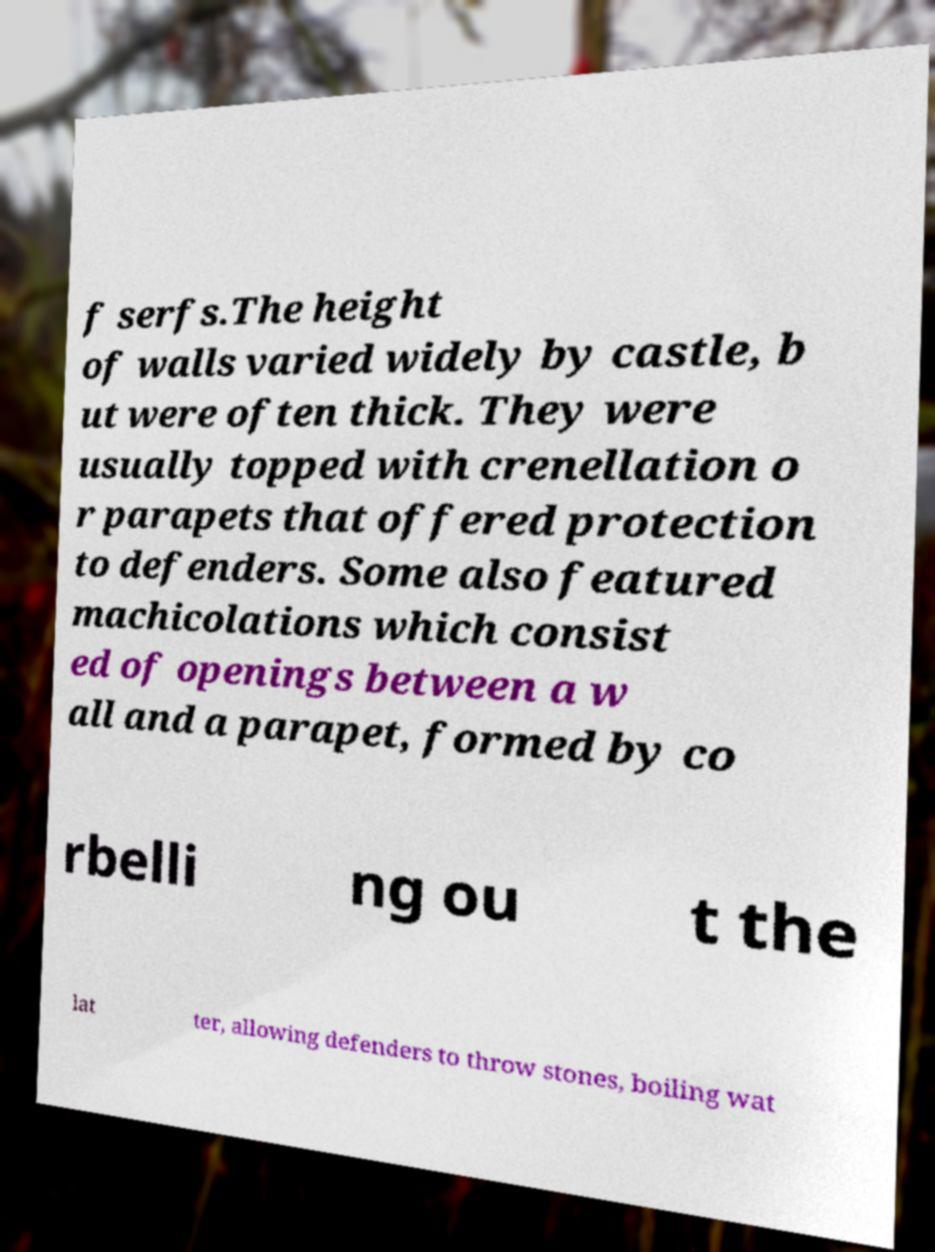Please read and relay the text visible in this image. What does it say? f serfs.The height of walls varied widely by castle, b ut were often thick. They were usually topped with crenellation o r parapets that offered protection to defenders. Some also featured machicolations which consist ed of openings between a w all and a parapet, formed by co rbelli ng ou t the lat ter, allowing defenders to throw stones, boiling wat 